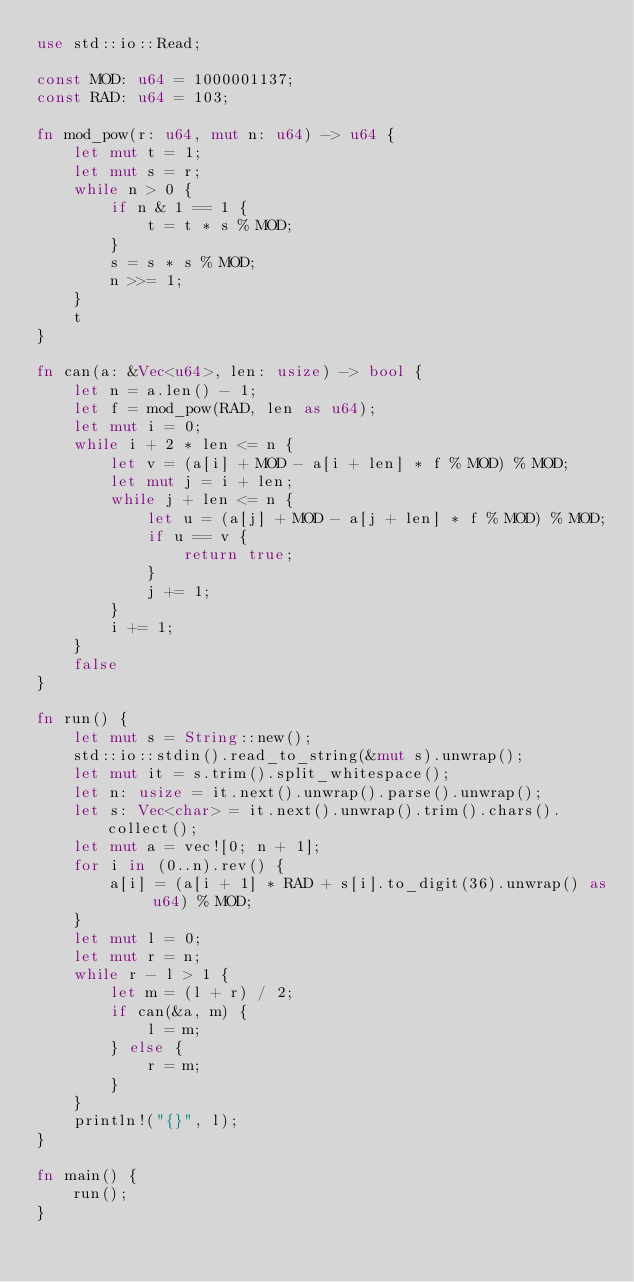Convert code to text. <code><loc_0><loc_0><loc_500><loc_500><_Rust_>use std::io::Read;

const MOD: u64 = 1000001137;
const RAD: u64 = 103;

fn mod_pow(r: u64, mut n: u64) -> u64 {
    let mut t = 1;
    let mut s = r;
    while n > 0 {
        if n & 1 == 1 {
            t = t * s % MOD;
        }
        s = s * s % MOD;
        n >>= 1;
    }
    t
}

fn can(a: &Vec<u64>, len: usize) -> bool {
    let n = a.len() - 1;
    let f = mod_pow(RAD, len as u64);
    let mut i = 0;
    while i + 2 * len <= n {
        let v = (a[i] + MOD - a[i + len] * f % MOD) % MOD;
        let mut j = i + len;
        while j + len <= n {
            let u = (a[j] + MOD - a[j + len] * f % MOD) % MOD;
            if u == v {
                return true;
            }
            j += 1;
        }
        i += 1;
    }
    false
}

fn run() {
    let mut s = String::new();
    std::io::stdin().read_to_string(&mut s).unwrap();
    let mut it = s.trim().split_whitespace();
    let n: usize = it.next().unwrap().parse().unwrap();
    let s: Vec<char> = it.next().unwrap().trim().chars().collect();
    let mut a = vec![0; n + 1];
    for i in (0..n).rev() {
        a[i] = (a[i + 1] * RAD + s[i].to_digit(36).unwrap() as u64) % MOD;
    }
    let mut l = 0;
    let mut r = n;
    while r - l > 1 {
        let m = (l + r) / 2;
        if can(&a, m) {
            l = m;
        } else {
            r = m;
        }
    }
    println!("{}", l);
}

fn main() {
    run();
}
</code> 